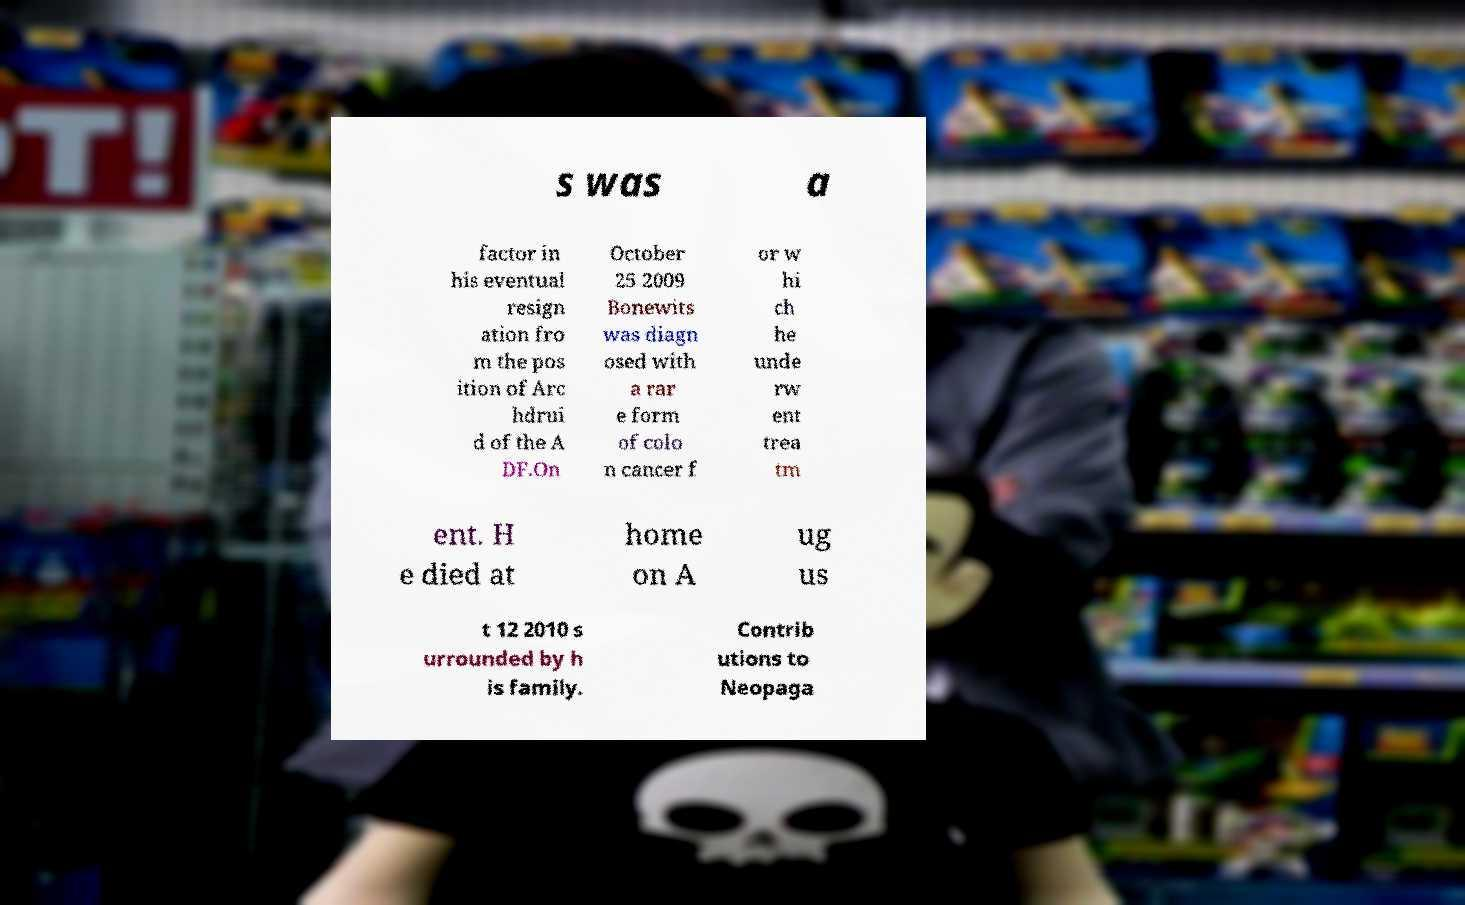Can you accurately transcribe the text from the provided image for me? s was a factor in his eventual resign ation fro m the pos ition of Arc hdrui d of the A DF.On October 25 2009 Bonewits was diagn osed with a rar e form of colo n cancer f or w hi ch he unde rw ent trea tm ent. H e died at home on A ug us t 12 2010 s urrounded by h is family. Contrib utions to Neopaga 